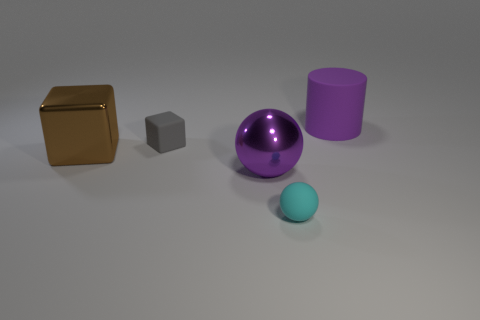What number of balls are behind the large brown metal cube? 0 